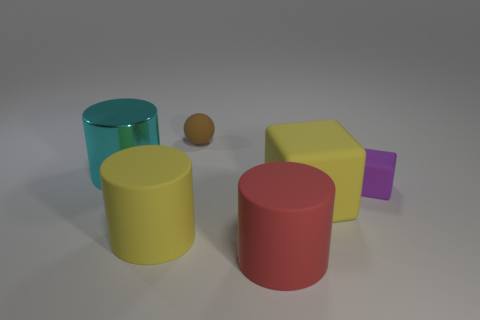Add 3 cyan shiny things. How many objects exist? 9 Subtract all balls. How many objects are left? 5 Subtract 0 blue cylinders. How many objects are left? 6 Subtract all large cyan shiny objects. Subtract all tiny red things. How many objects are left? 5 Add 1 big cyan metal things. How many big cyan metal things are left? 2 Add 3 small red balls. How many small red balls exist? 3 